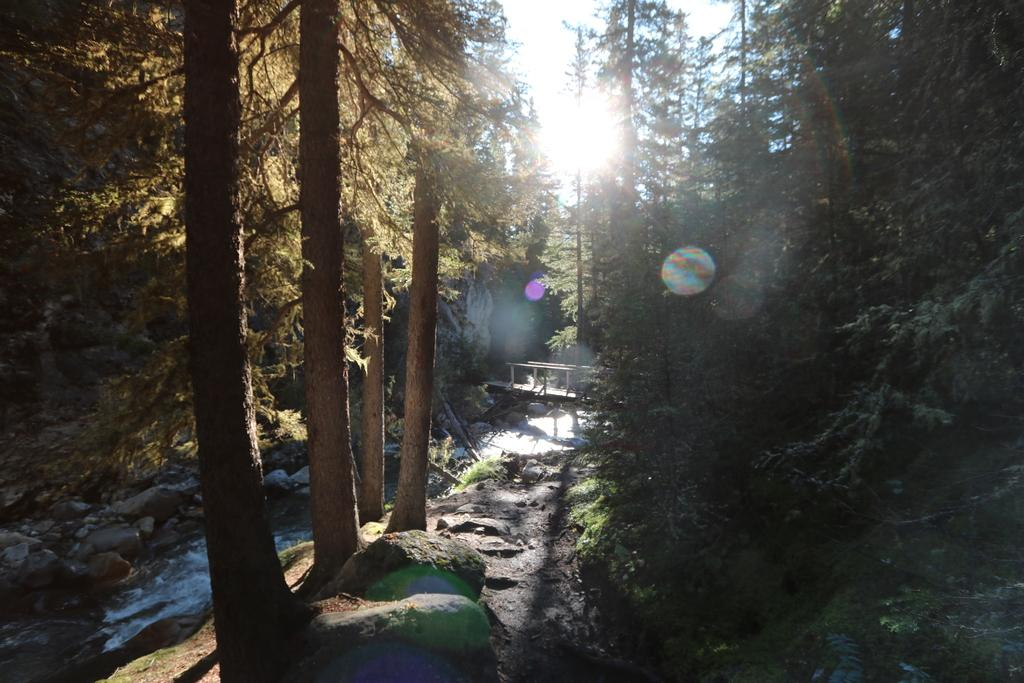What type of natural elements can be seen in the image? There are trees and rocks on the ground visible in the image. What is happening with the water in the image? There is water flowing in the image. How can someone cross the water in the image? There is a wooden bridge across the water in the image. What is visible at the top of the image? The sky is visible at the top of the image. How many lizards are sitting on the seat in the image? There is no seat or lizards present in the image. 